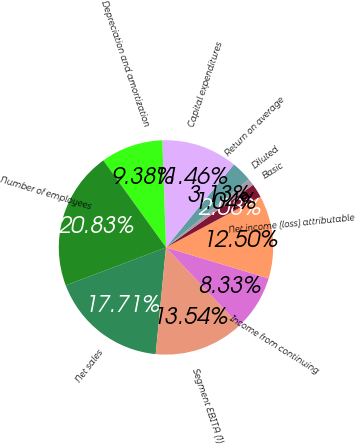Convert chart. <chart><loc_0><loc_0><loc_500><loc_500><pie_chart><fcel>Net sales<fcel>Segment EBITA (1)<fcel>Income from continuing<fcel>Net income (loss) attributable<fcel>Basic<fcel>Diluted<fcel>Return on average<fcel>Capital expenditures<fcel>Depreciation and amortization<fcel>Number of employees<nl><fcel>17.71%<fcel>13.54%<fcel>8.33%<fcel>12.5%<fcel>2.08%<fcel>1.04%<fcel>3.13%<fcel>11.46%<fcel>9.38%<fcel>20.83%<nl></chart> 